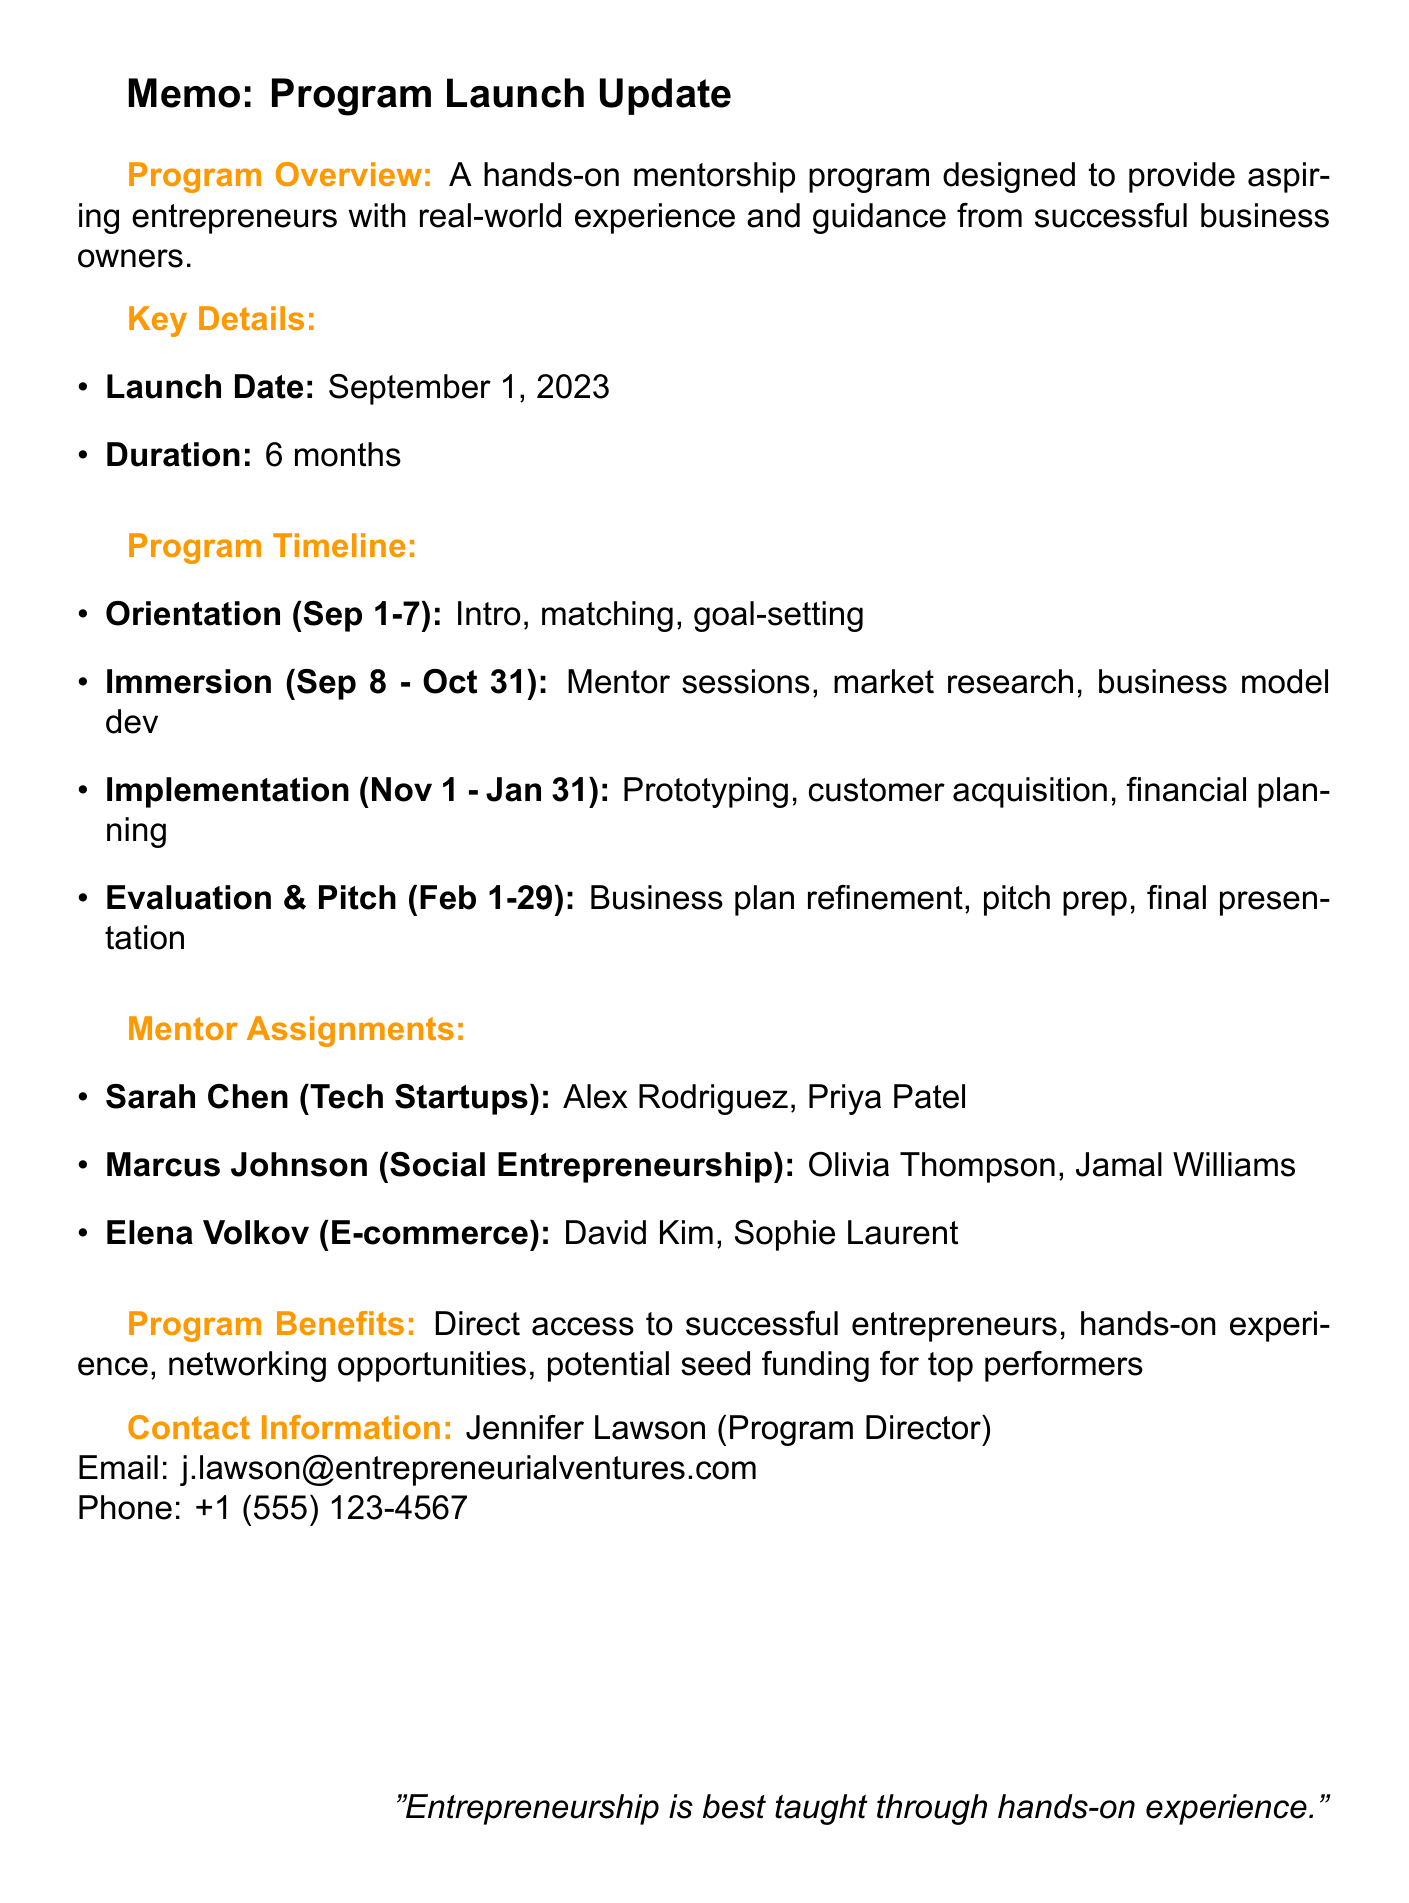What is the program name? The program name is stated at the beginning of the memo as "Entrepreneurial Ventures Mentorship Program."
Answer: Entrepreneurial Ventures Mentorship Program When does the program launch? The launch date is specifically mentioned in the document, which is September 1, 2023.
Answer: September 1, 2023 How long is the duration of the program? The duration is indicated explicitly, which is 6 months.
Answer: 6 months Who is the program director? The program director's name is provided in the contact information section of the memo.
Answer: Jennifer Lawson What are the key objectives of the program? The document lists key objectives including practical skills, learning from mentors, innovative thinking, and developing business acumen.
Answer: Foster practical entrepreneurial skills, Facilitate direct learning from experienced mentors, Encourage innovative thinking and problem-solving, Develop business acumen through real-world challenges Which phase includes pitch deck preparation? This pertains to a specific phase mentioned in the timeline, so one can find the answer there.
Answer: Evaluation and Pitch How many mentees are assigned to Sarah Chen? By counting the mentees listed under Sarah Chen in the mentor assignments section, the answer can be derived.
Answer: 2 What metrics will measure success? The success metrics are outlined in the document and include various criteria for evaluation.
Answer: Number of viable business plans developed, Percentage of participants launching businesses within 6 months of program completion, Mentor satisfaction ratings, Amount of seed funding secured by participants Who are the partners of the program? The document lists the program partners, making the answer clear.
Answer: TechStars Accelerator, Local Chamber of Commerce, Silicon Valley Bank 